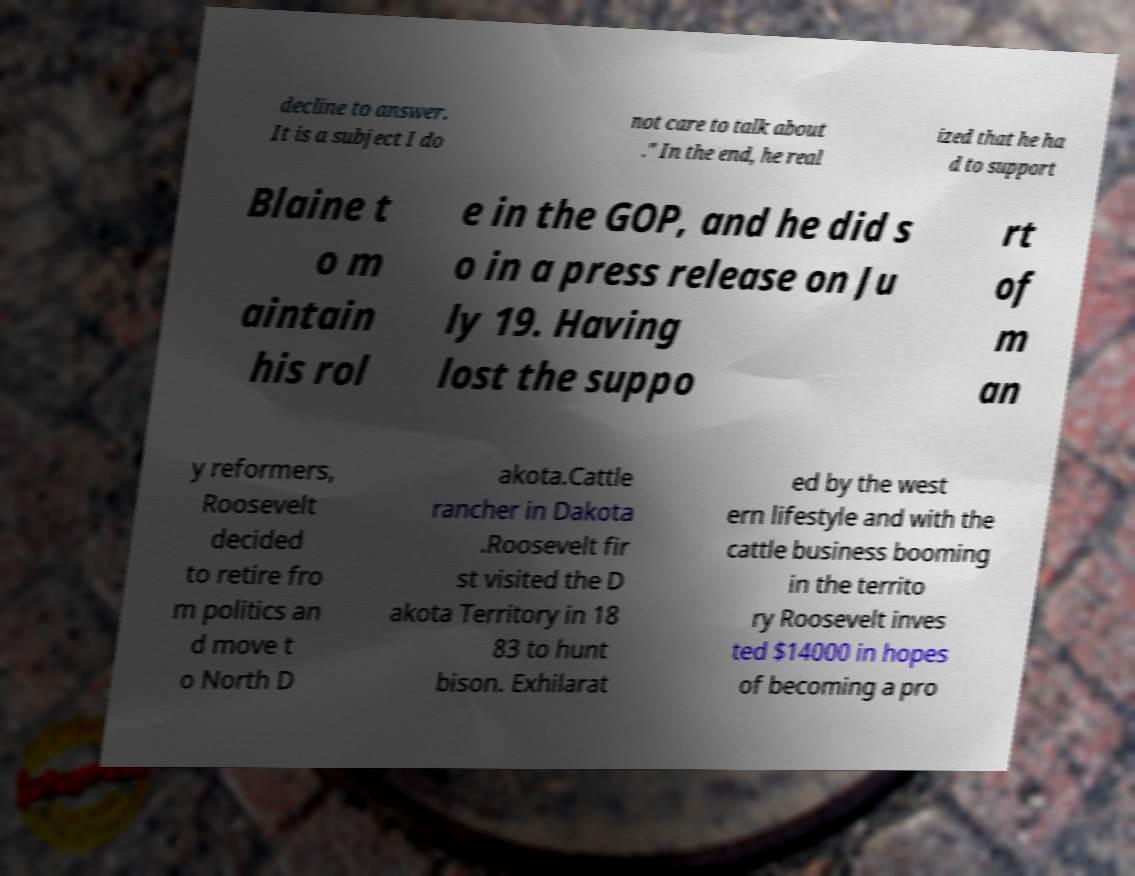Can you read and provide the text displayed in the image?This photo seems to have some interesting text. Can you extract and type it out for me? decline to answer. It is a subject I do not care to talk about ." In the end, he real ized that he ha d to support Blaine t o m aintain his rol e in the GOP, and he did s o in a press release on Ju ly 19. Having lost the suppo rt of m an y reformers, Roosevelt decided to retire fro m politics an d move t o North D akota.Cattle rancher in Dakota .Roosevelt fir st visited the D akota Territory in 18 83 to hunt bison. Exhilarat ed by the west ern lifestyle and with the cattle business booming in the territo ry Roosevelt inves ted $14000 in hopes of becoming a pro 